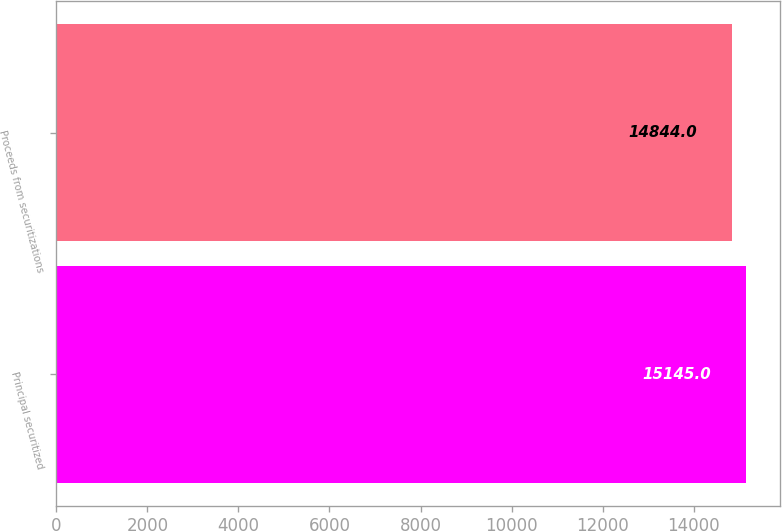Convert chart to OTSL. <chart><loc_0><loc_0><loc_500><loc_500><bar_chart><fcel>Principal securitized<fcel>Proceeds from securitizations<nl><fcel>15145<fcel>14844<nl></chart> 